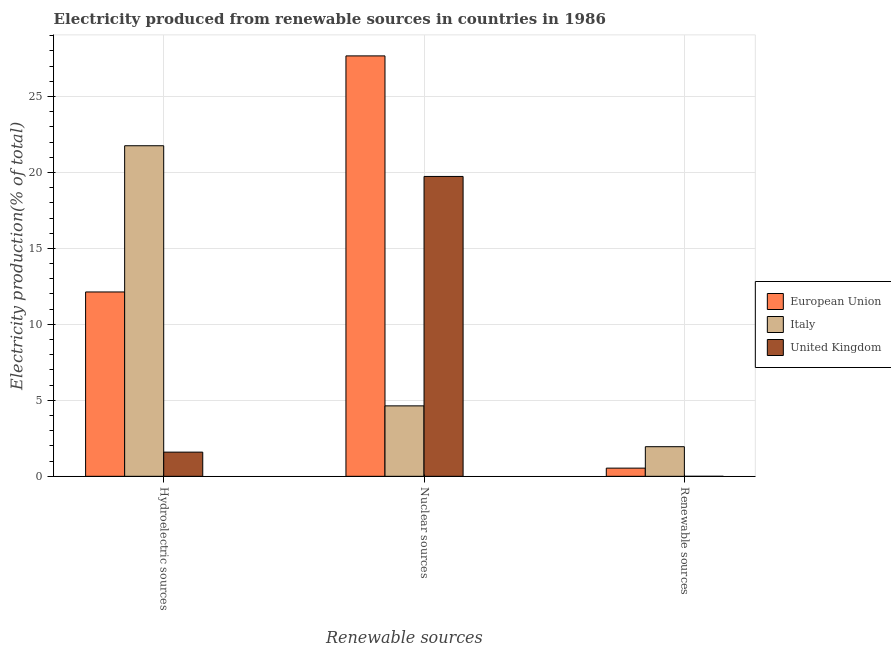How many different coloured bars are there?
Ensure brevity in your answer.  3. Are the number of bars per tick equal to the number of legend labels?
Your answer should be very brief. Yes. How many bars are there on the 2nd tick from the left?
Provide a succinct answer. 3. How many bars are there on the 1st tick from the right?
Offer a very short reply. 3. What is the label of the 2nd group of bars from the left?
Provide a short and direct response. Nuclear sources. What is the percentage of electricity produced by renewable sources in Italy?
Ensure brevity in your answer.  1.95. Across all countries, what is the maximum percentage of electricity produced by nuclear sources?
Your answer should be compact. 27.67. Across all countries, what is the minimum percentage of electricity produced by nuclear sources?
Your answer should be very brief. 4.64. What is the total percentage of electricity produced by nuclear sources in the graph?
Your answer should be very brief. 52.04. What is the difference between the percentage of electricity produced by renewable sources in European Union and that in United Kingdom?
Your answer should be compact. 0.54. What is the difference between the percentage of electricity produced by hydroelectric sources in European Union and the percentage of electricity produced by renewable sources in United Kingdom?
Your answer should be very brief. 12.13. What is the average percentage of electricity produced by nuclear sources per country?
Your answer should be compact. 17.35. What is the difference between the percentage of electricity produced by nuclear sources and percentage of electricity produced by renewable sources in Italy?
Your answer should be compact. 2.69. What is the ratio of the percentage of electricity produced by hydroelectric sources in European Union to that in Italy?
Ensure brevity in your answer.  0.56. Is the percentage of electricity produced by nuclear sources in United Kingdom less than that in European Union?
Your answer should be very brief. Yes. Is the difference between the percentage of electricity produced by hydroelectric sources in European Union and Italy greater than the difference between the percentage of electricity produced by nuclear sources in European Union and Italy?
Provide a short and direct response. No. What is the difference between the highest and the second highest percentage of electricity produced by renewable sources?
Your answer should be compact. 1.41. What is the difference between the highest and the lowest percentage of electricity produced by renewable sources?
Keep it short and to the point. 1.95. In how many countries, is the percentage of electricity produced by renewable sources greater than the average percentage of electricity produced by renewable sources taken over all countries?
Your response must be concise. 1. What does the 2nd bar from the left in Hydroelectric sources represents?
Ensure brevity in your answer.  Italy. What does the 1st bar from the right in Nuclear sources represents?
Provide a short and direct response. United Kingdom. How many bars are there?
Ensure brevity in your answer.  9. Are all the bars in the graph horizontal?
Your answer should be compact. No. How many countries are there in the graph?
Your response must be concise. 3. Does the graph contain any zero values?
Provide a short and direct response. No. Where does the legend appear in the graph?
Your answer should be very brief. Center right. How many legend labels are there?
Make the answer very short. 3. How are the legend labels stacked?
Offer a very short reply. Vertical. What is the title of the graph?
Provide a short and direct response. Electricity produced from renewable sources in countries in 1986. Does "Egypt, Arab Rep." appear as one of the legend labels in the graph?
Your response must be concise. No. What is the label or title of the X-axis?
Make the answer very short. Renewable sources. What is the label or title of the Y-axis?
Make the answer very short. Electricity production(% of total). What is the Electricity production(% of total) in European Union in Hydroelectric sources?
Offer a very short reply. 12.13. What is the Electricity production(% of total) in Italy in Hydroelectric sources?
Your answer should be very brief. 21.76. What is the Electricity production(% of total) of United Kingdom in Hydroelectric sources?
Offer a terse response. 1.59. What is the Electricity production(% of total) in European Union in Nuclear sources?
Provide a succinct answer. 27.67. What is the Electricity production(% of total) in Italy in Nuclear sources?
Offer a very short reply. 4.64. What is the Electricity production(% of total) of United Kingdom in Nuclear sources?
Give a very brief answer. 19.74. What is the Electricity production(% of total) in European Union in Renewable sources?
Offer a terse response. 0.54. What is the Electricity production(% of total) of Italy in Renewable sources?
Give a very brief answer. 1.95. What is the Electricity production(% of total) in United Kingdom in Renewable sources?
Keep it short and to the point. 0. Across all Renewable sources, what is the maximum Electricity production(% of total) of European Union?
Your answer should be compact. 27.67. Across all Renewable sources, what is the maximum Electricity production(% of total) in Italy?
Offer a very short reply. 21.76. Across all Renewable sources, what is the maximum Electricity production(% of total) in United Kingdom?
Offer a very short reply. 19.74. Across all Renewable sources, what is the minimum Electricity production(% of total) of European Union?
Give a very brief answer. 0.54. Across all Renewable sources, what is the minimum Electricity production(% of total) in Italy?
Provide a short and direct response. 1.95. Across all Renewable sources, what is the minimum Electricity production(% of total) of United Kingdom?
Your response must be concise. 0. What is the total Electricity production(% of total) in European Union in the graph?
Your response must be concise. 40.34. What is the total Electricity production(% of total) of Italy in the graph?
Provide a succinct answer. 28.34. What is the total Electricity production(% of total) of United Kingdom in the graph?
Your response must be concise. 21.33. What is the difference between the Electricity production(% of total) of European Union in Hydroelectric sources and that in Nuclear sources?
Keep it short and to the point. -15.54. What is the difference between the Electricity production(% of total) of Italy in Hydroelectric sources and that in Nuclear sources?
Your response must be concise. 17.12. What is the difference between the Electricity production(% of total) of United Kingdom in Hydroelectric sources and that in Nuclear sources?
Ensure brevity in your answer.  -18.14. What is the difference between the Electricity production(% of total) in European Union in Hydroelectric sources and that in Renewable sources?
Provide a short and direct response. 11.59. What is the difference between the Electricity production(% of total) of Italy in Hydroelectric sources and that in Renewable sources?
Keep it short and to the point. 19.81. What is the difference between the Electricity production(% of total) in United Kingdom in Hydroelectric sources and that in Renewable sources?
Your response must be concise. 1.59. What is the difference between the Electricity production(% of total) in European Union in Nuclear sources and that in Renewable sources?
Give a very brief answer. 27.13. What is the difference between the Electricity production(% of total) of Italy in Nuclear sources and that in Renewable sources?
Offer a terse response. 2.69. What is the difference between the Electricity production(% of total) in United Kingdom in Nuclear sources and that in Renewable sources?
Offer a terse response. 19.74. What is the difference between the Electricity production(% of total) of European Union in Hydroelectric sources and the Electricity production(% of total) of Italy in Nuclear sources?
Keep it short and to the point. 7.5. What is the difference between the Electricity production(% of total) in European Union in Hydroelectric sources and the Electricity production(% of total) in United Kingdom in Nuclear sources?
Your answer should be compact. -7.6. What is the difference between the Electricity production(% of total) of Italy in Hydroelectric sources and the Electricity production(% of total) of United Kingdom in Nuclear sources?
Your answer should be very brief. 2.02. What is the difference between the Electricity production(% of total) of European Union in Hydroelectric sources and the Electricity production(% of total) of Italy in Renewable sources?
Your answer should be very brief. 10.18. What is the difference between the Electricity production(% of total) of European Union in Hydroelectric sources and the Electricity production(% of total) of United Kingdom in Renewable sources?
Offer a terse response. 12.13. What is the difference between the Electricity production(% of total) in Italy in Hydroelectric sources and the Electricity production(% of total) in United Kingdom in Renewable sources?
Keep it short and to the point. 21.76. What is the difference between the Electricity production(% of total) of European Union in Nuclear sources and the Electricity production(% of total) of Italy in Renewable sources?
Make the answer very short. 25.72. What is the difference between the Electricity production(% of total) of European Union in Nuclear sources and the Electricity production(% of total) of United Kingdom in Renewable sources?
Offer a very short reply. 27.67. What is the difference between the Electricity production(% of total) in Italy in Nuclear sources and the Electricity production(% of total) in United Kingdom in Renewable sources?
Make the answer very short. 4.64. What is the average Electricity production(% of total) in European Union per Renewable sources?
Offer a terse response. 13.45. What is the average Electricity production(% of total) of Italy per Renewable sources?
Keep it short and to the point. 9.45. What is the average Electricity production(% of total) in United Kingdom per Renewable sources?
Ensure brevity in your answer.  7.11. What is the difference between the Electricity production(% of total) of European Union and Electricity production(% of total) of Italy in Hydroelectric sources?
Give a very brief answer. -9.62. What is the difference between the Electricity production(% of total) of European Union and Electricity production(% of total) of United Kingdom in Hydroelectric sources?
Ensure brevity in your answer.  10.54. What is the difference between the Electricity production(% of total) in Italy and Electricity production(% of total) in United Kingdom in Hydroelectric sources?
Your answer should be compact. 20.16. What is the difference between the Electricity production(% of total) of European Union and Electricity production(% of total) of Italy in Nuclear sources?
Give a very brief answer. 23.03. What is the difference between the Electricity production(% of total) in European Union and Electricity production(% of total) in United Kingdom in Nuclear sources?
Make the answer very short. 7.93. What is the difference between the Electricity production(% of total) of Italy and Electricity production(% of total) of United Kingdom in Nuclear sources?
Make the answer very short. -15.1. What is the difference between the Electricity production(% of total) in European Union and Electricity production(% of total) in Italy in Renewable sources?
Offer a terse response. -1.41. What is the difference between the Electricity production(% of total) of European Union and Electricity production(% of total) of United Kingdom in Renewable sources?
Ensure brevity in your answer.  0.54. What is the difference between the Electricity production(% of total) of Italy and Electricity production(% of total) of United Kingdom in Renewable sources?
Make the answer very short. 1.95. What is the ratio of the Electricity production(% of total) in European Union in Hydroelectric sources to that in Nuclear sources?
Offer a very short reply. 0.44. What is the ratio of the Electricity production(% of total) in Italy in Hydroelectric sources to that in Nuclear sources?
Give a very brief answer. 4.69. What is the ratio of the Electricity production(% of total) of United Kingdom in Hydroelectric sources to that in Nuclear sources?
Provide a short and direct response. 0.08. What is the ratio of the Electricity production(% of total) in European Union in Hydroelectric sources to that in Renewable sources?
Offer a terse response. 22.51. What is the ratio of the Electricity production(% of total) in Italy in Hydroelectric sources to that in Renewable sources?
Make the answer very short. 11.16. What is the ratio of the Electricity production(% of total) of United Kingdom in Hydroelectric sources to that in Renewable sources?
Ensure brevity in your answer.  4766. What is the ratio of the Electricity production(% of total) in European Union in Nuclear sources to that in Renewable sources?
Your answer should be very brief. 51.33. What is the ratio of the Electricity production(% of total) in Italy in Nuclear sources to that in Renewable sources?
Your answer should be compact. 2.38. What is the ratio of the Electricity production(% of total) in United Kingdom in Nuclear sources to that in Renewable sources?
Make the answer very short. 5.91e+04. What is the difference between the highest and the second highest Electricity production(% of total) in European Union?
Offer a very short reply. 15.54. What is the difference between the highest and the second highest Electricity production(% of total) in Italy?
Ensure brevity in your answer.  17.12. What is the difference between the highest and the second highest Electricity production(% of total) in United Kingdom?
Keep it short and to the point. 18.14. What is the difference between the highest and the lowest Electricity production(% of total) in European Union?
Ensure brevity in your answer.  27.13. What is the difference between the highest and the lowest Electricity production(% of total) of Italy?
Offer a very short reply. 19.81. What is the difference between the highest and the lowest Electricity production(% of total) of United Kingdom?
Keep it short and to the point. 19.74. 